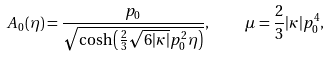Convert formula to latex. <formula><loc_0><loc_0><loc_500><loc_500>A _ { 0 } ( \eta ) = \frac { p _ { 0 } } { \sqrt { \cosh \left ( \frac { 2 } { 3 } \sqrt { 6 | \kappa | } p _ { 0 } ^ { 2 } \eta \right ) } } , \quad \mu = \frac { 2 } { 3 } | \kappa | p _ { 0 } ^ { 4 } ,</formula> 